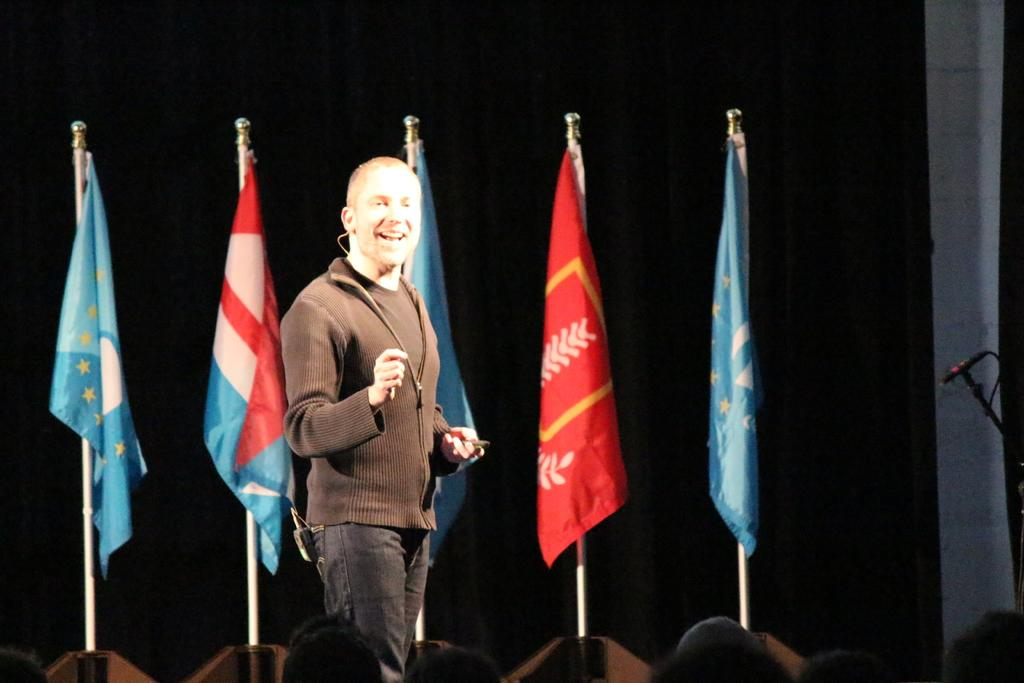What is the man in the image doing? The man is standing in the image and smiling. How many flags can be seen in the background of the image? There are five flags in the background of the image. What is the color of the background in the image? The background of the image is dark. What can be seen at the bottom of the image? People's heads are visible at the bottom of the image. What type of skin condition is visible on the man's face in the image? There is no indication of any skin condition on the man's face in the image. Can you see a gun in the man's hand in the image? There is no gun visible in the man's hand or anywhere else in the image. 